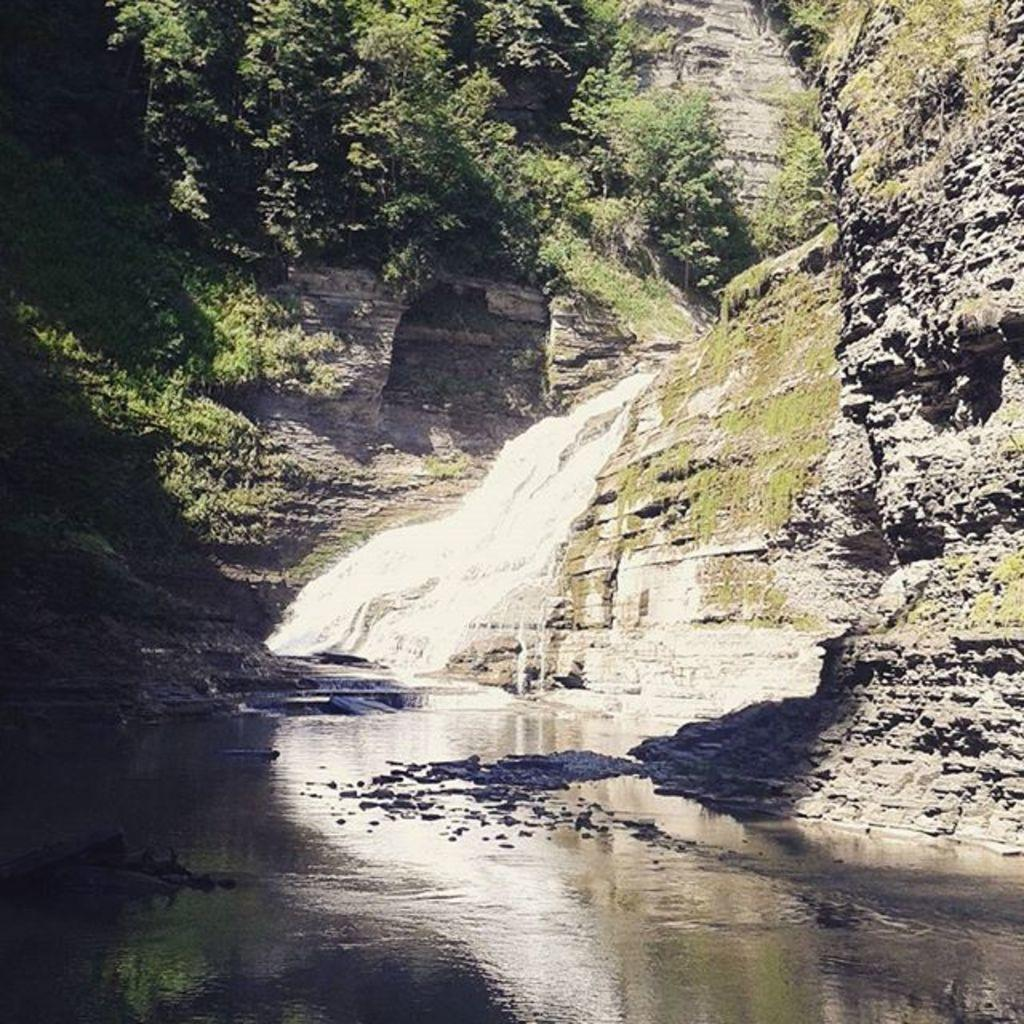What natural feature is the main subject of the image? There is a waterfall in the image. What type of vegetation can be seen in the image? There are trees in the image. What geographical feature is visible in the background of the image? There are mountains in the image. What time of day might the image have been taken? The image was likely taken during the day, as the lighting suggests it is daytime. What type of beef is being discussed by the committee in the image? There is no committee or beef present in the image; it features a waterfall, trees, and mountains. What type of weather can be seen in the image? The image does not show any specific weather conditions; it simply depicts a waterfall, trees, and mountains. 